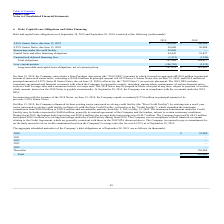From Plexus's financial document, Which years does the table provide information for the company's Debt and capital lease obligations? The document shows two values: 2019 and 2018. From the document: "2019 2018 2019 2018..." Also, What was the amount of Capital lease and other financing obligations in 2018? According to the financial document, 39,857 (in thousands). The relevant text states: "ital lease and other financing obligations 44,492 39,857..." Also, What was the amount of total obligations in 2019? According to the financial document, 287,980 (in thousands). The relevant text states: "Total obligations 287,980 188,617..." Also, How many years did Capital lease and other financing obligations exceed $40,000 thousand? Based on the analysis, there are 1 instances. The counting process: 2019. Also, can you calculate: What was the change in the Unamortized deferred financing fees between 2018 and 2019? Based on the calculation: -1,512-(-1,240), the result is -272 (in thousands). This is based on the information: "Unamortized deferred financing fees (1,512) (1,240) Unamortized deferred financing fees (1,512) (1,240)..." The key data points involved are: 1,240, 1,512. Also, can you calculate: What was the percentage change in Total obligations between 2018 and 2019? To answer this question, I need to perform calculations using the financial data. The calculation is: (287,980-188,617)/188,617, which equals 52.68 (percentage). This is based on the information: "Total obligations 287,980 188,617 Total obligations 287,980 188,617..." The key data points involved are: 188,617, 287,980. 